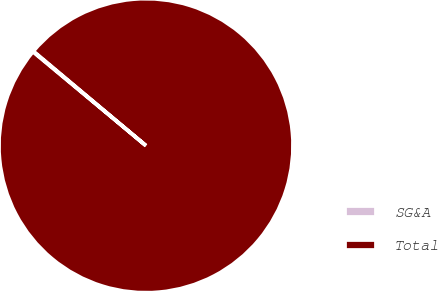Convert chart to OTSL. <chart><loc_0><loc_0><loc_500><loc_500><pie_chart><fcel>SG&A<fcel>Total<nl><fcel>0.08%<fcel>99.92%<nl></chart> 